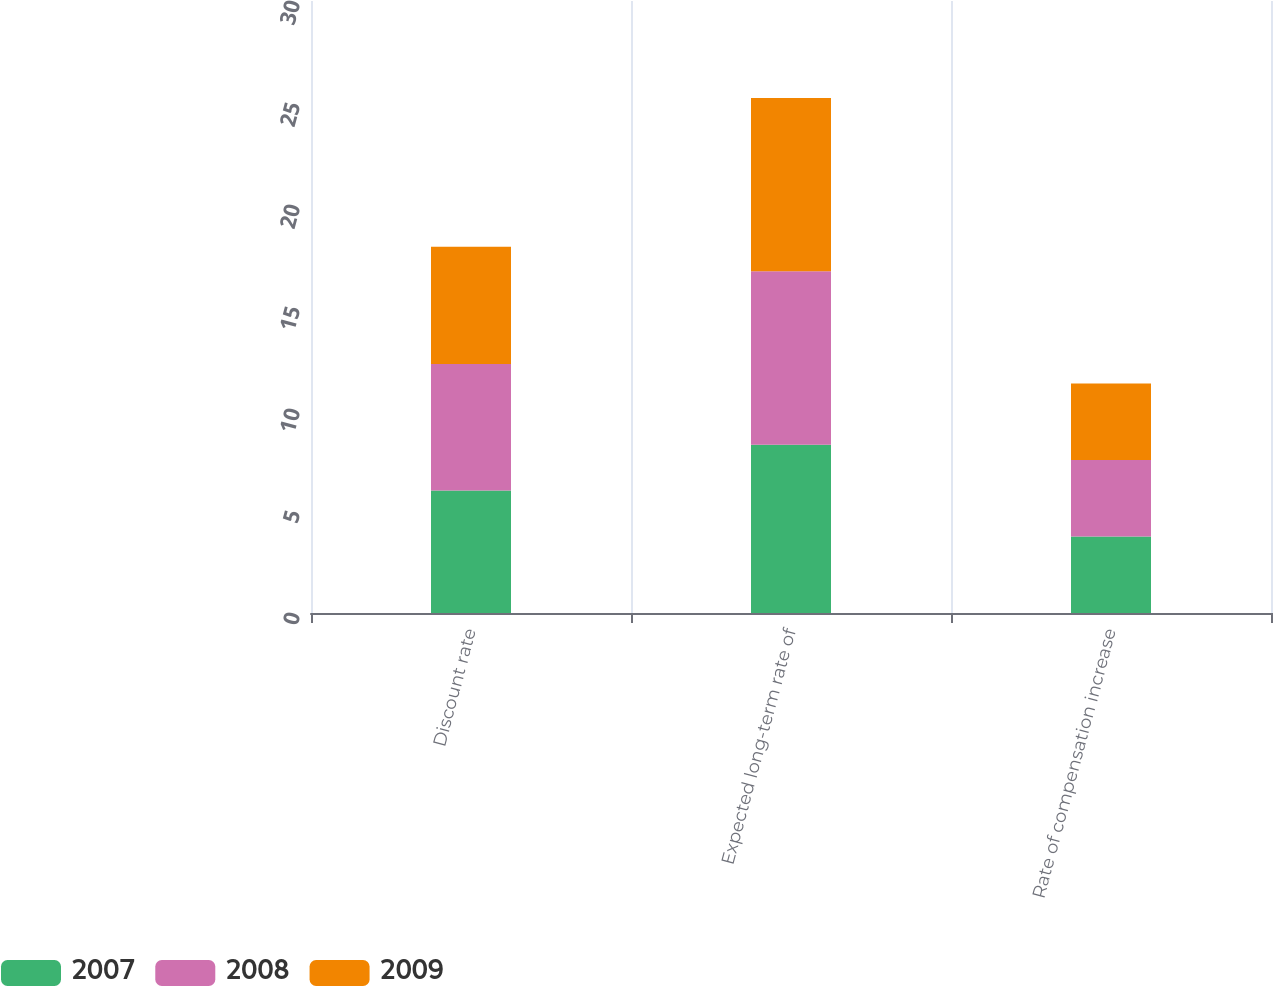Convert chart. <chart><loc_0><loc_0><loc_500><loc_500><stacked_bar_chart><ecel><fcel>Discount rate<fcel>Expected long-term rate of<fcel>Rate of compensation increase<nl><fcel>2007<fcel>6<fcel>8.25<fcel>3.75<nl><fcel>2008<fcel>6.2<fcel>8.5<fcel>3.75<nl><fcel>2009<fcel>5.75<fcel>8.5<fcel>3.75<nl></chart> 